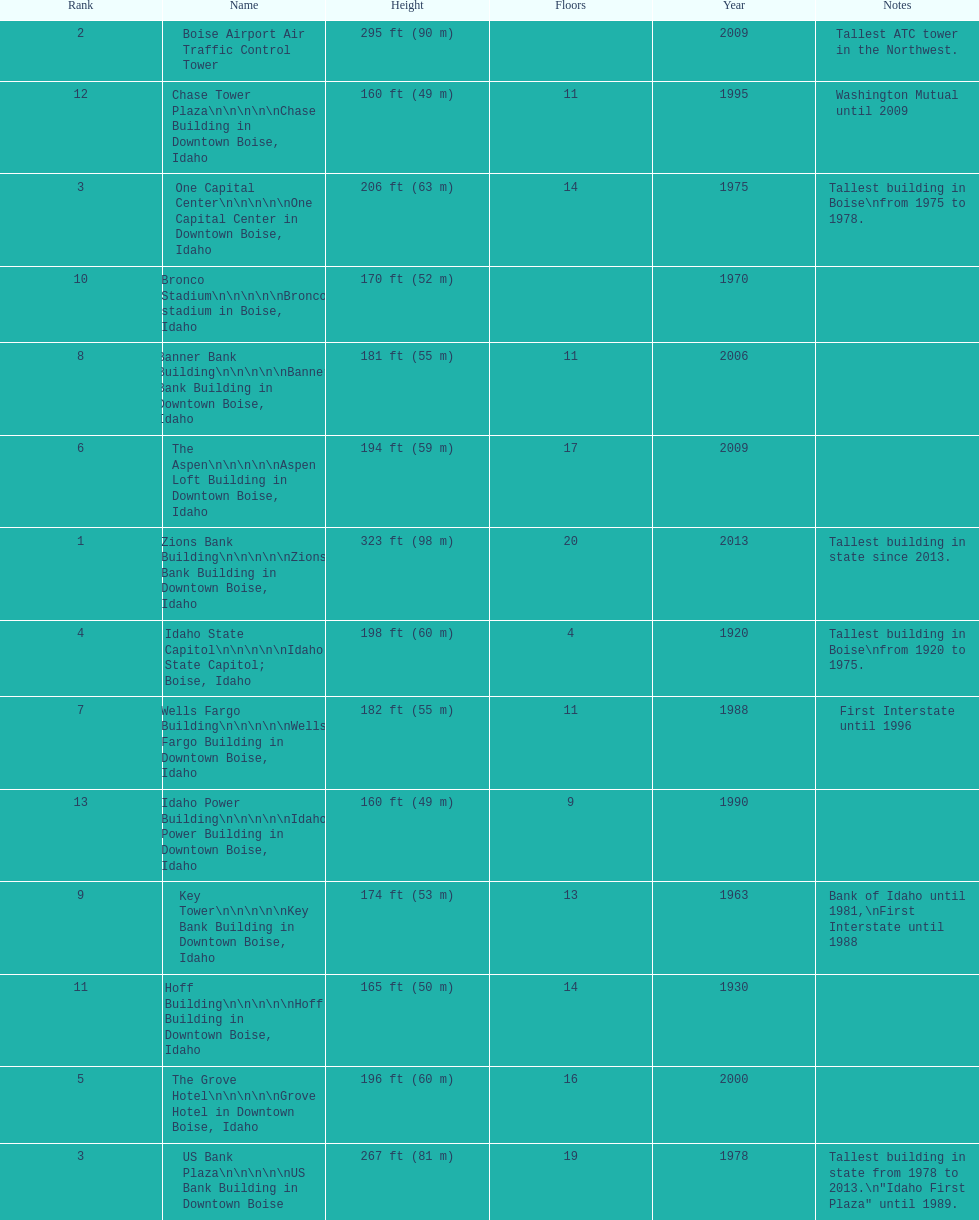What are the number of floors the us bank plaza has? 19. 